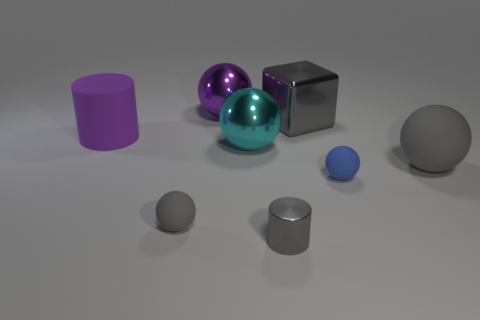How do the different textures of the objects contribute to the overall feel of the scene? The interplay of textures adds variety to the scene. The metallic sheen of the cube and the spheres gives a sleek, modern feel, while the matte finish of the cylinder seems soft and almost velvety. This contrast in textures generates visual interest and depth within the composition. 